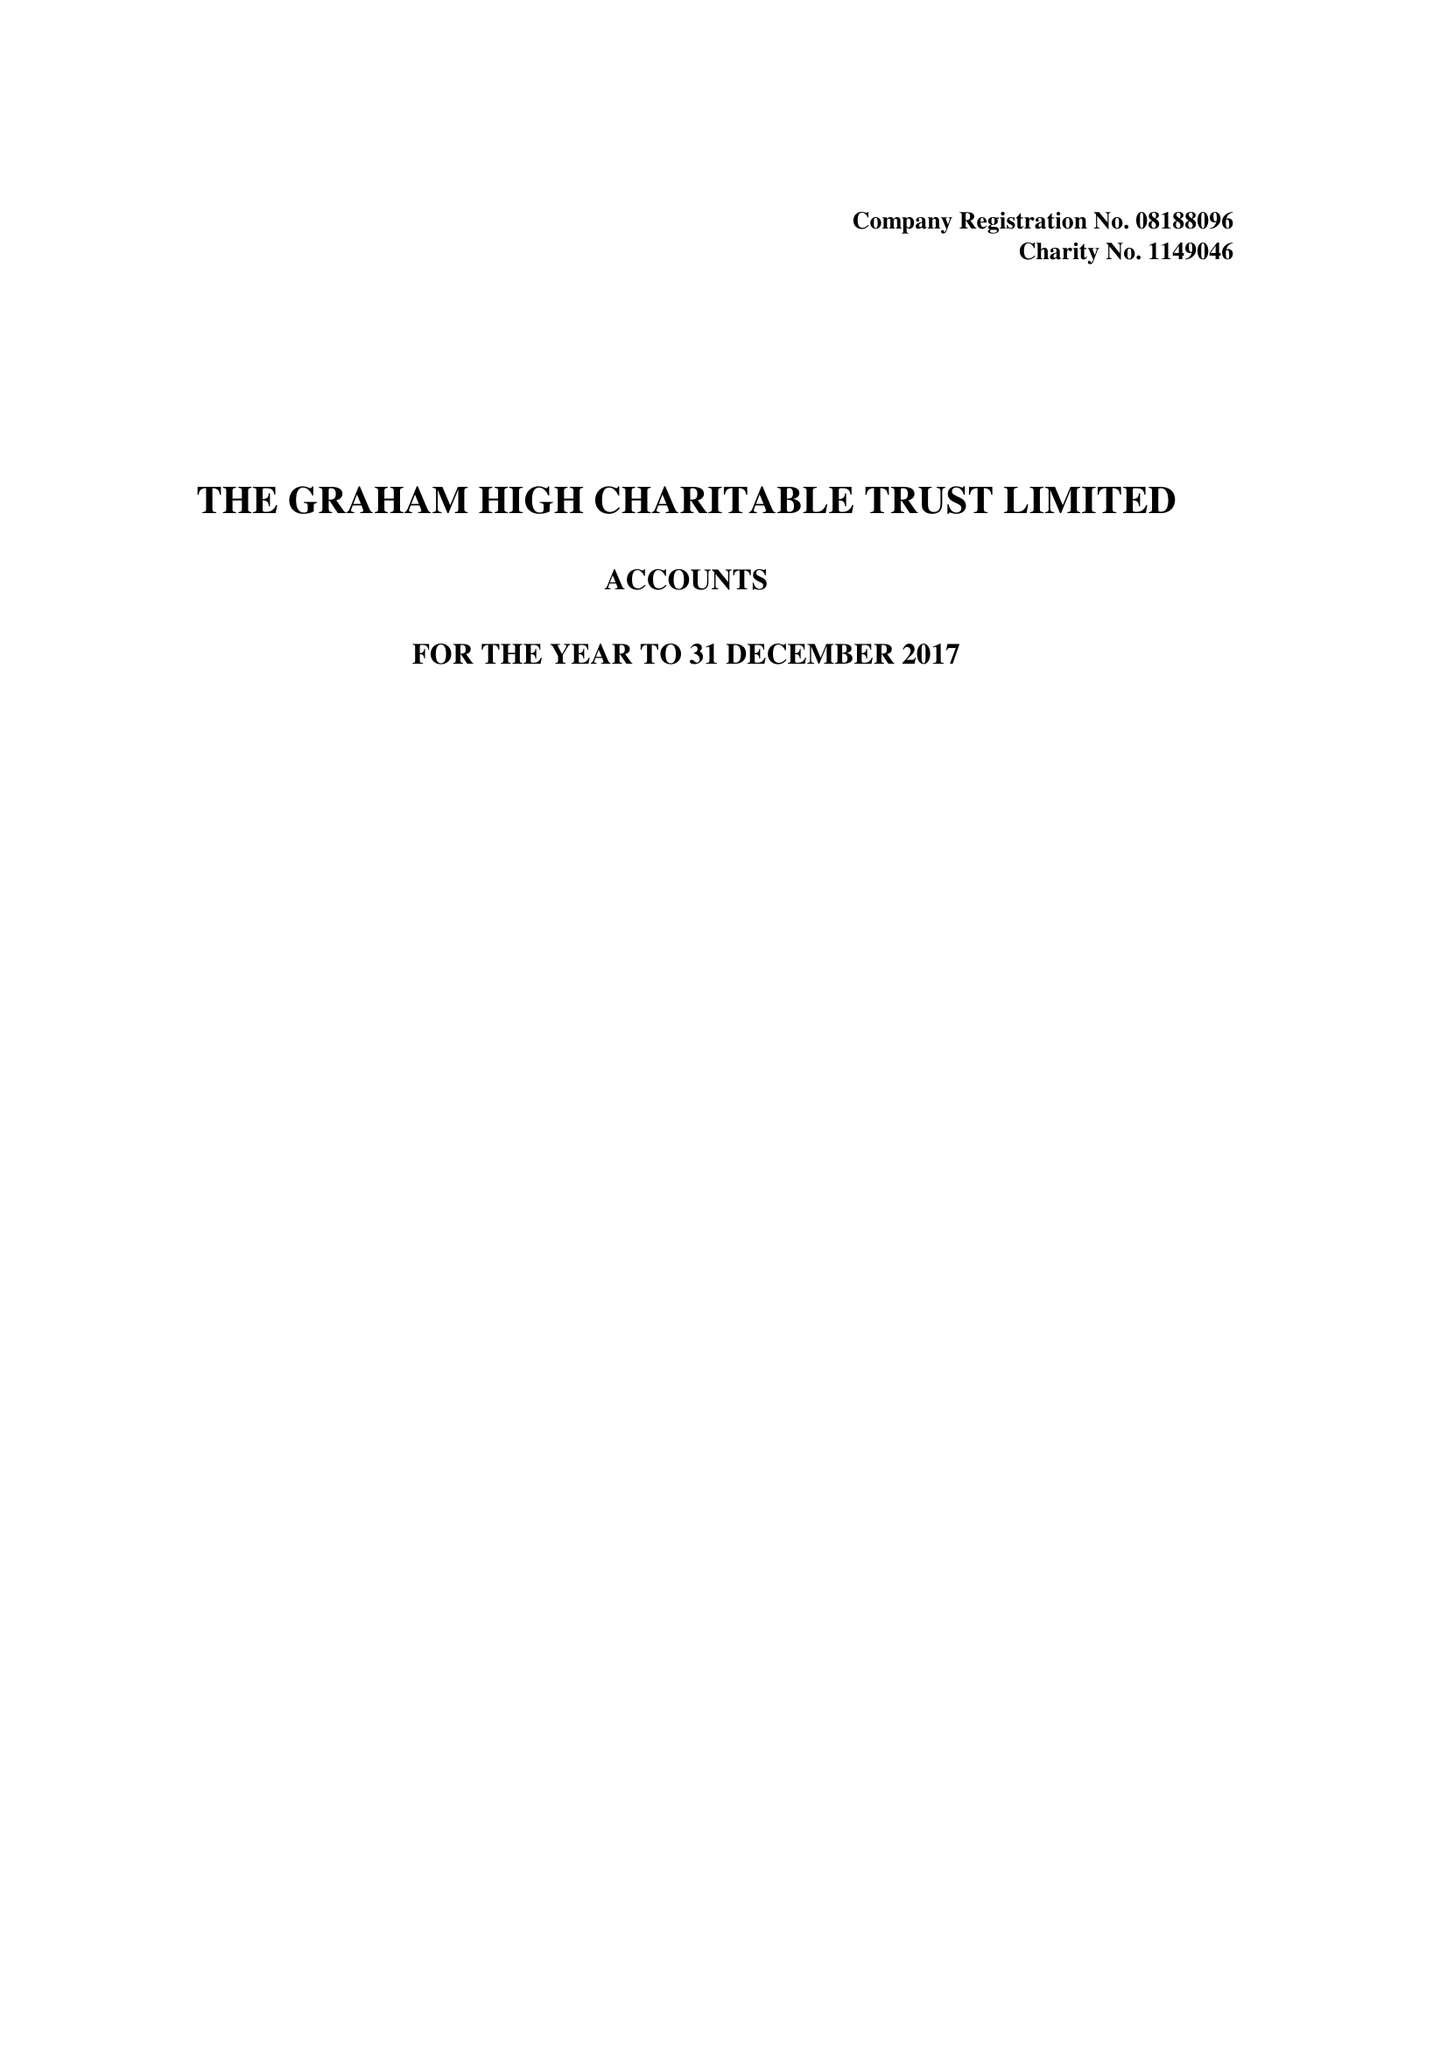What is the value for the charity_number?
Answer the question using a single word or phrase. 1149046 